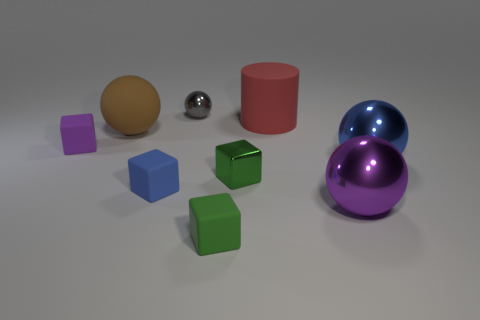Subtract all cyan spheres. Subtract all gray cubes. How many spheres are left? 4 Add 1 red cylinders. How many objects exist? 10 Subtract all spheres. How many objects are left? 5 Subtract all tiny green metal cubes. Subtract all big red shiny objects. How many objects are left? 8 Add 2 big blue shiny balls. How many big blue shiny balls are left? 3 Add 5 large brown metallic balls. How many large brown metallic balls exist? 5 Subtract 0 cyan spheres. How many objects are left? 9 